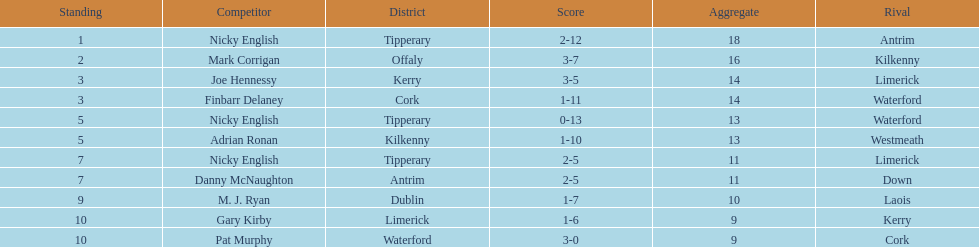Joe hennessy and finbarr delaney both scored how many points? 14. 